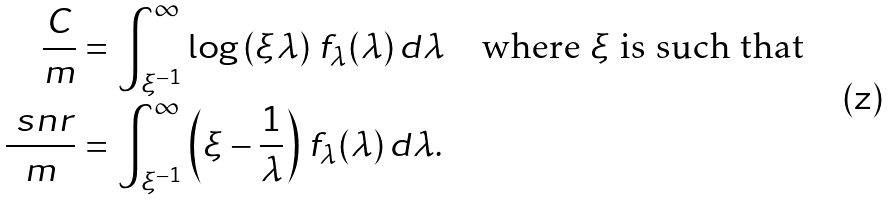Convert formula to latex. <formula><loc_0><loc_0><loc_500><loc_500>\frac { C } { m } & = \int _ { \xi ^ { - 1 } } ^ { \infty } \log \left ( \xi \lambda \right ) \, f _ { \lambda } ( \lambda ) \, d \lambda \quad \text {where $\xi$ is such   that} \\ \frac { \ s n r } { m } & = \int _ { \xi ^ { - 1 } } ^ { \infty } \left ( \xi - \frac { 1 } { \lambda } \right ) \, f _ { \lambda } ( \lambda ) \, d \lambda .</formula> 